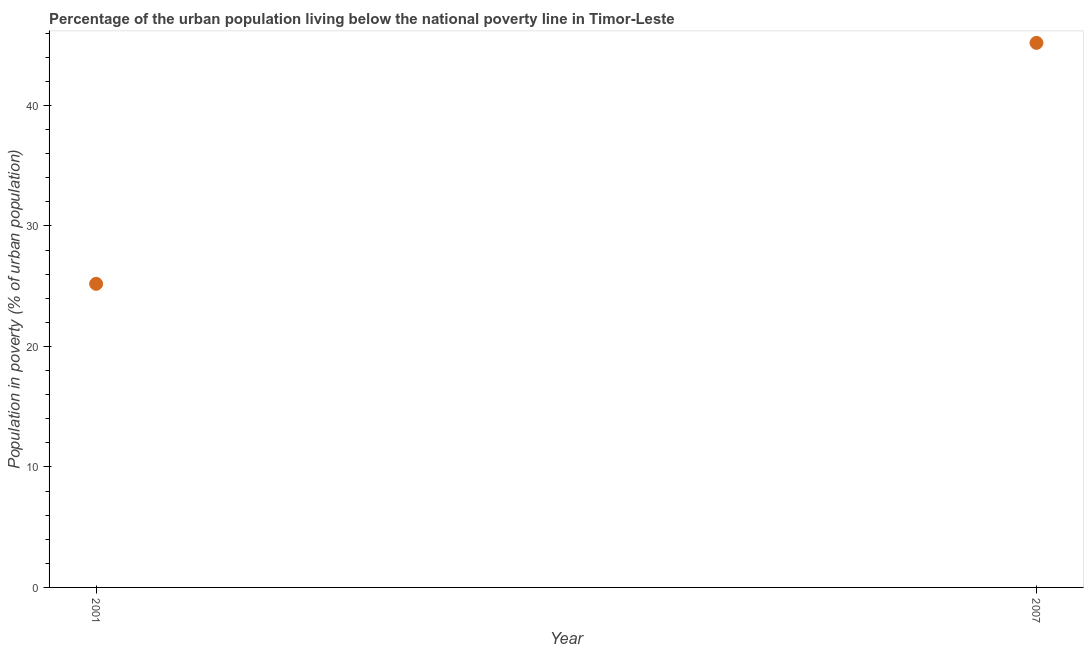What is the percentage of urban population living below poverty line in 2007?
Your answer should be compact. 45.2. Across all years, what is the maximum percentage of urban population living below poverty line?
Provide a succinct answer. 45.2. Across all years, what is the minimum percentage of urban population living below poverty line?
Make the answer very short. 25.2. What is the sum of the percentage of urban population living below poverty line?
Your response must be concise. 70.4. What is the difference between the percentage of urban population living below poverty line in 2001 and 2007?
Provide a short and direct response. -20. What is the average percentage of urban population living below poverty line per year?
Keep it short and to the point. 35.2. What is the median percentage of urban population living below poverty line?
Provide a succinct answer. 35.2. In how many years, is the percentage of urban population living below poverty line greater than 12 %?
Your answer should be compact. 2. What is the ratio of the percentage of urban population living below poverty line in 2001 to that in 2007?
Your answer should be compact. 0.56. Is the percentage of urban population living below poverty line in 2001 less than that in 2007?
Your answer should be very brief. Yes. In how many years, is the percentage of urban population living below poverty line greater than the average percentage of urban population living below poverty line taken over all years?
Offer a terse response. 1. What is the difference between two consecutive major ticks on the Y-axis?
Offer a very short reply. 10. Are the values on the major ticks of Y-axis written in scientific E-notation?
Make the answer very short. No. Does the graph contain any zero values?
Your answer should be compact. No. What is the title of the graph?
Provide a short and direct response. Percentage of the urban population living below the national poverty line in Timor-Leste. What is the label or title of the X-axis?
Offer a very short reply. Year. What is the label or title of the Y-axis?
Your answer should be very brief. Population in poverty (% of urban population). What is the Population in poverty (% of urban population) in 2001?
Provide a short and direct response. 25.2. What is the Population in poverty (% of urban population) in 2007?
Provide a short and direct response. 45.2. What is the ratio of the Population in poverty (% of urban population) in 2001 to that in 2007?
Offer a very short reply. 0.56. 